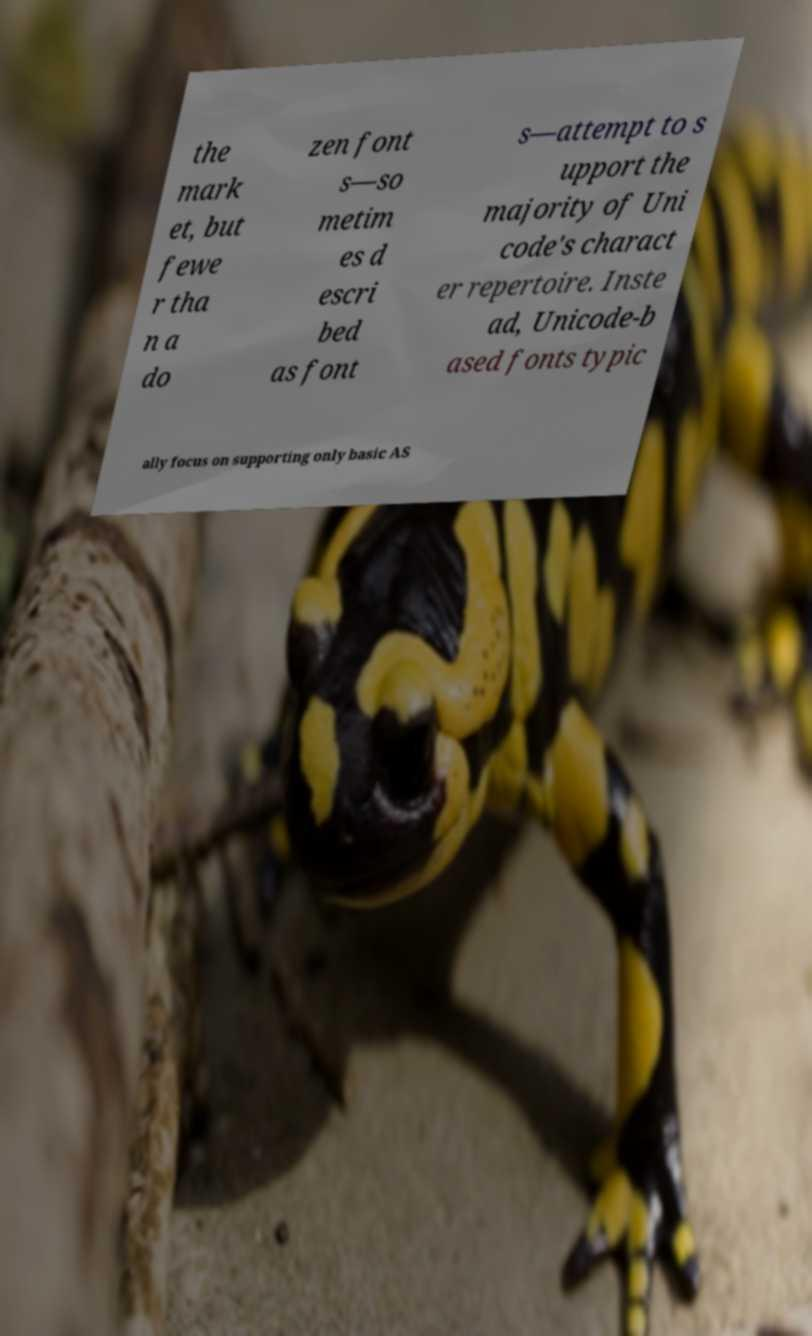There's text embedded in this image that I need extracted. Can you transcribe it verbatim? the mark et, but fewe r tha n a do zen font s—so metim es d escri bed as font s—attempt to s upport the majority of Uni code's charact er repertoire. Inste ad, Unicode-b ased fonts typic ally focus on supporting only basic AS 